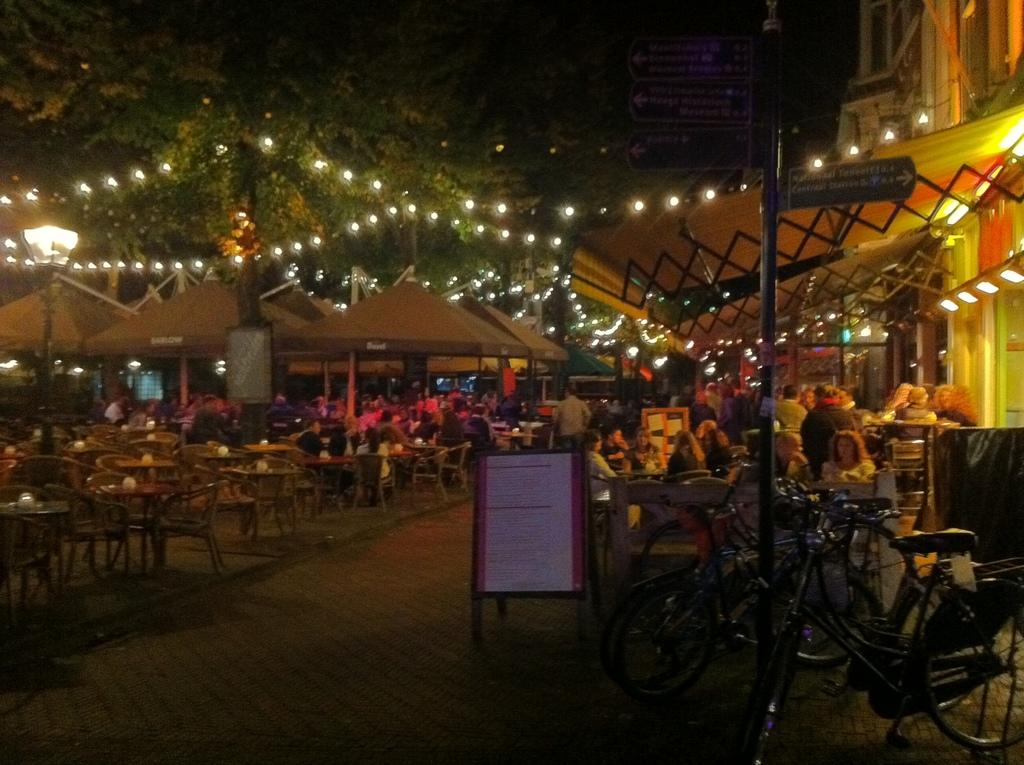How many people are visible in the image? There are many people in the image. What type of furniture is present in the image? There are chairs and tables in the image. What other objects can be seen in the image? There are boards, poles, a building, lights, trees, and bicycles in the image. What type of writer is sitting on the bicycle in the image? There is no writer or bicycle present in the image. How does the tramp interact with the poles in the image? There is no tramp present in the image, and therefore no interaction with the poles can be observed. 